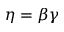<formula> <loc_0><loc_0><loc_500><loc_500>\eta = \beta \gamma</formula> 